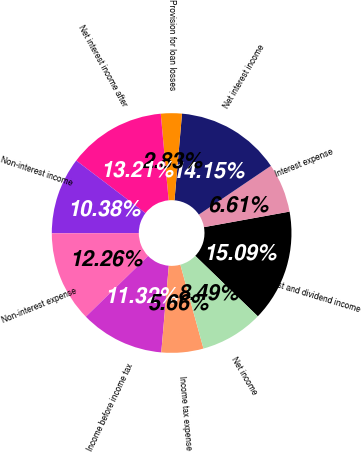<chart> <loc_0><loc_0><loc_500><loc_500><pie_chart><fcel>Interest and dividend income<fcel>Interest expense<fcel>Net interest income<fcel>Provision for loan losses<fcel>Net interest income after<fcel>Non-interest income<fcel>Non-interest expense<fcel>Income before income tax<fcel>Income tax expense<fcel>Net income<nl><fcel>15.09%<fcel>6.61%<fcel>14.15%<fcel>2.83%<fcel>13.21%<fcel>10.38%<fcel>12.26%<fcel>11.32%<fcel>5.66%<fcel>8.49%<nl></chart> 